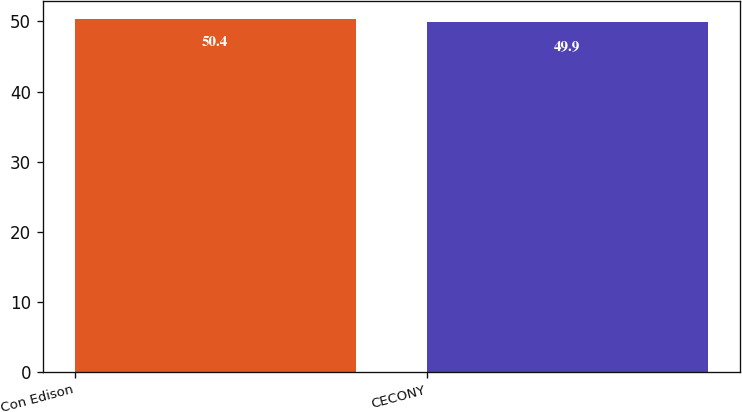<chart> <loc_0><loc_0><loc_500><loc_500><bar_chart><fcel>Con Edison<fcel>CECONY<nl><fcel>50.4<fcel>49.9<nl></chart> 